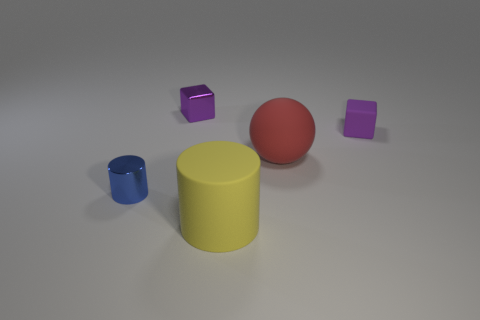Add 4 blocks. How many objects exist? 9 Subtract all spheres. How many objects are left? 4 Add 1 green rubber objects. How many green rubber objects exist? 1 Subtract 0 purple cylinders. How many objects are left? 5 Subtract all small yellow matte blocks. Subtract all rubber things. How many objects are left? 2 Add 1 blue cylinders. How many blue cylinders are left? 2 